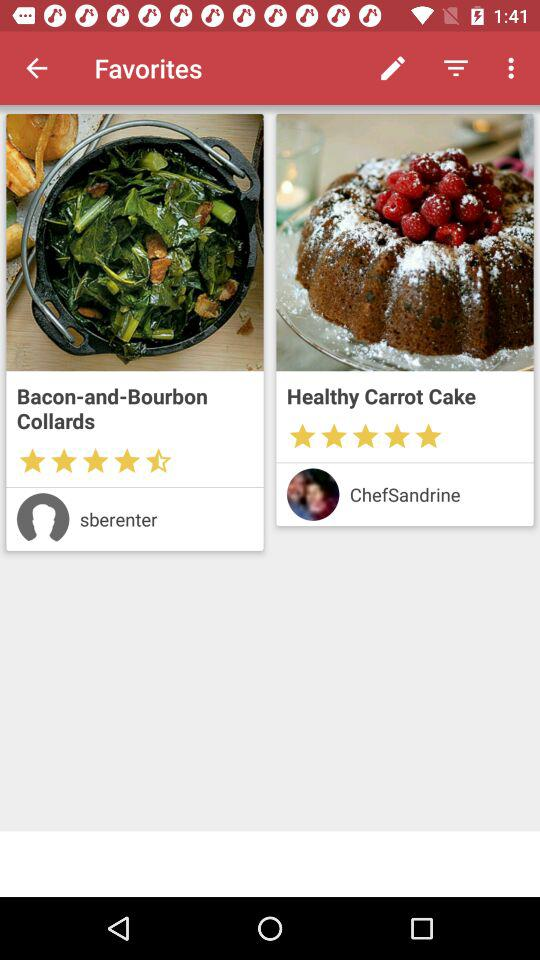What is the rating of the "Bacon-and-bourbon Collards"? The rating is 4.5 stars. 